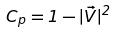<formula> <loc_0><loc_0><loc_500><loc_500>C _ { p } = 1 - | \vec { V } | ^ { 2 }</formula> 